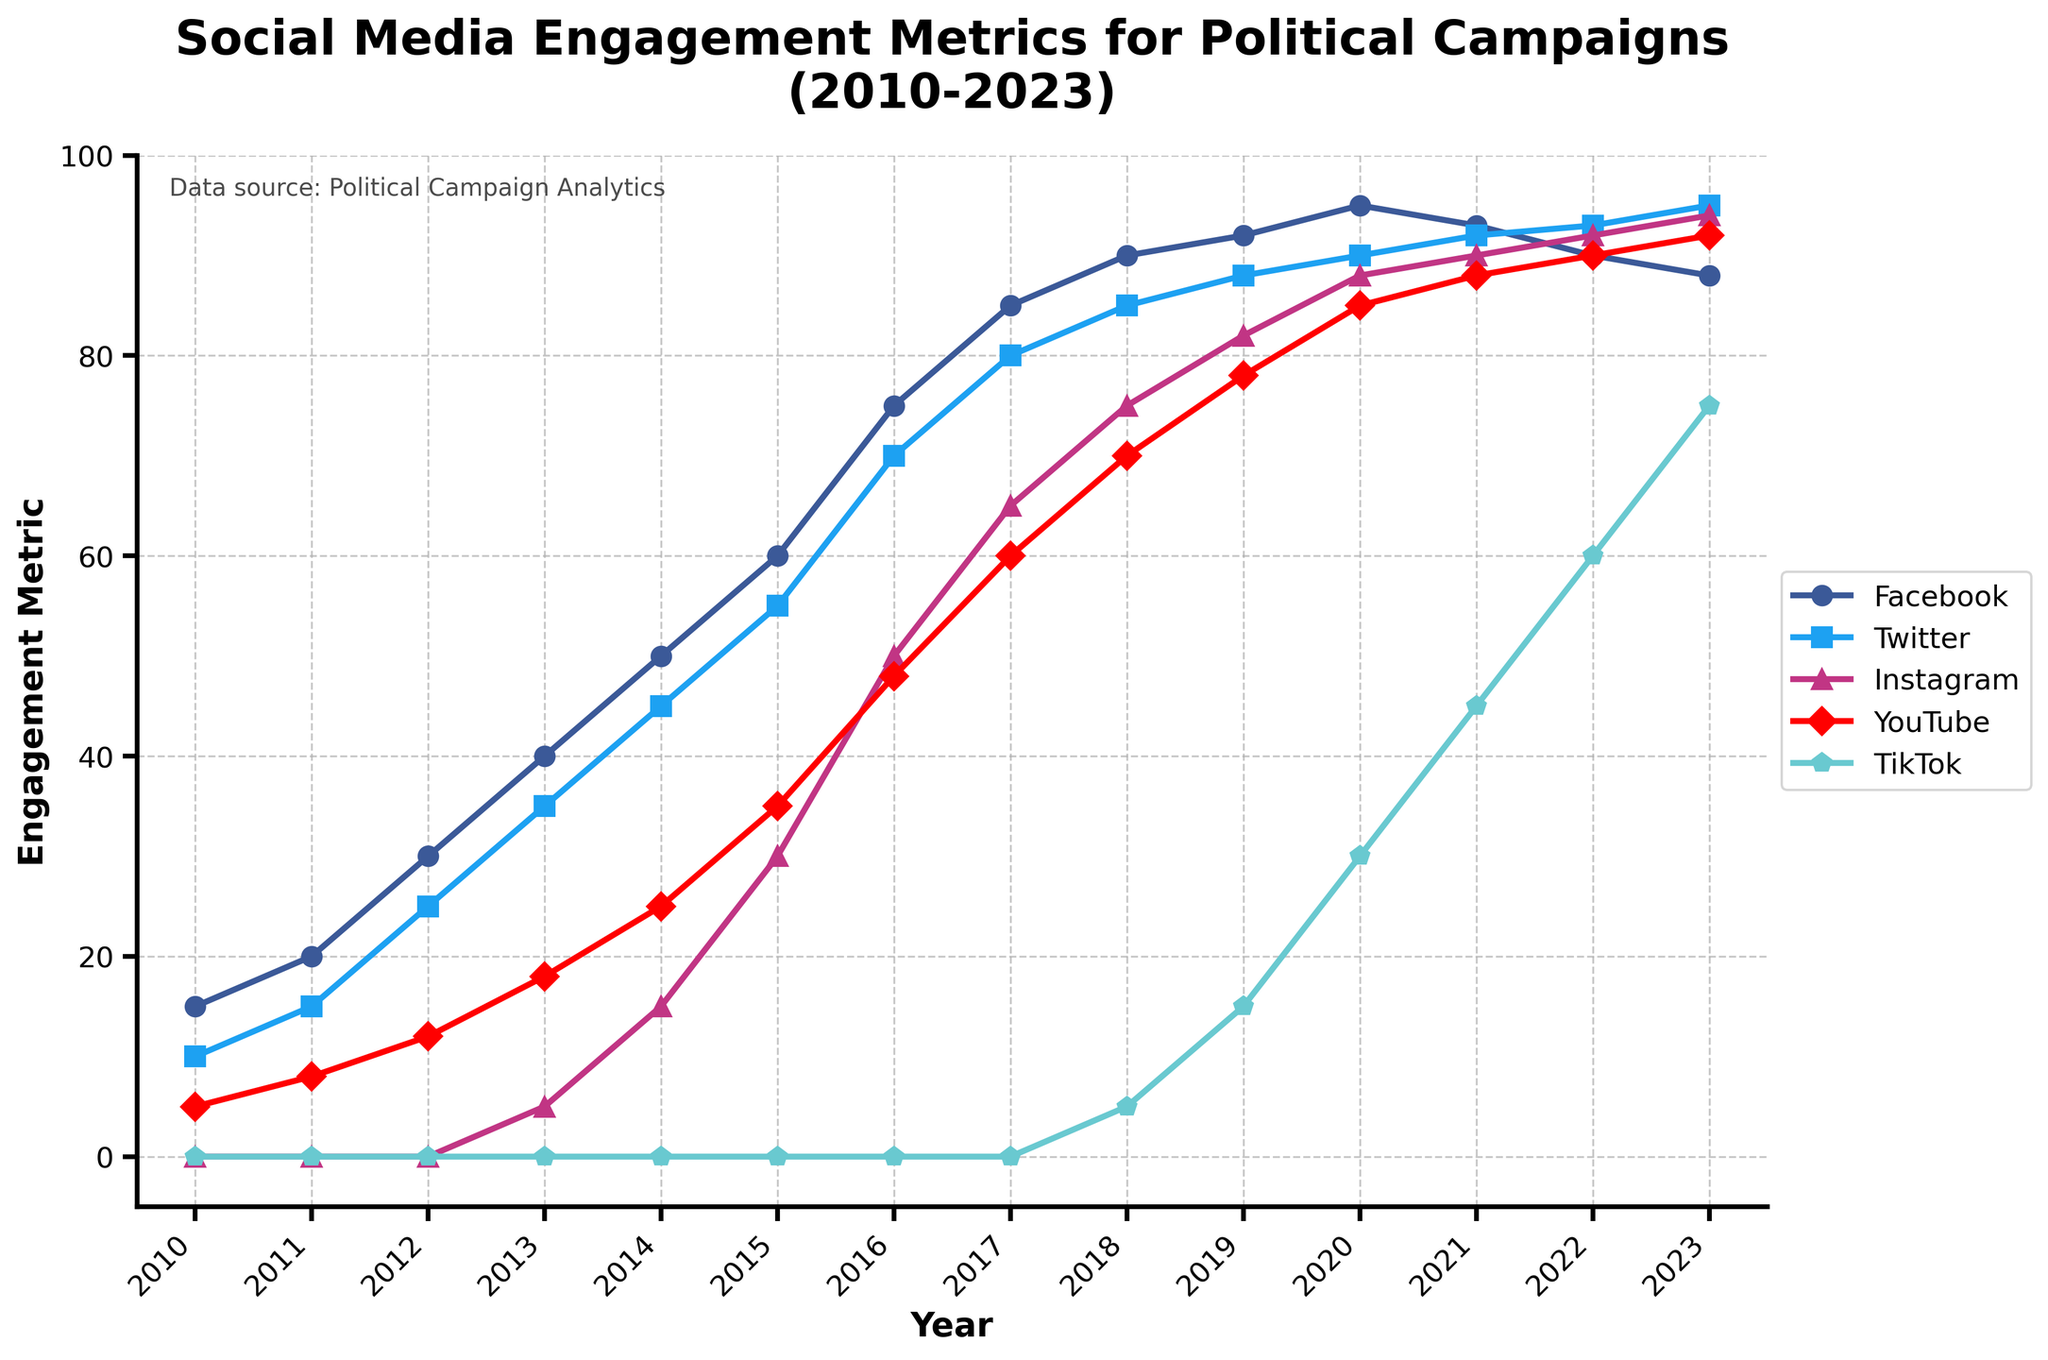How has TikTok's engagement changed from its first appearance in 2018 to 2023? TikTok showed zero engagement from 2010 to 2017. Starting in 2018, its engagement metrics are 5, 15, 30, 45, 60, and 75 in consecutive years up to 2023. This shows steady growth each year.
Answer: Increased from 5 to 75 Which platform had the highest engagement metric in 2023? By examining the endpoints of all lines in 2023, Facebook ends at 88, Twitter at 95, Instagram at 94, YouTube at 92, and TikTok at 75. Twitter has the highest engagement.
Answer: Twitter What year did Instagram start showing engagement metrics and what was the value? By looking at the lines, Instagram starts at the value of 0 up to 2012. From 2013, the line starts at 5.
Answer: 2013 and 5 In which year did YouTube surpass Facebook in engagement metrics? Examining both lines visually, YouTube overtakes Facebook in 2023 when Facebook has 88 and YouTube has 92.
Answer: 2023 From 2010 to 2023, which platform had the most consistent annual growth? TikTok shows the steadiest and most consistent growth pattern, increasing each year by almost the same amount since its introduction in 2018.
Answer: TikTok Between 2012 and 2016, which platform had the largest relative increase in engagement metrics? Facebook: 15 to 75 (60), Twitter: 25 to 70 (45), Instagram: 0 to 50 (50), YouTube: 12 to 48 (36). Instagram had the largest increase.
Answer: Instagram What's the difference in engagement metrics between Twitter and Instagram in 2020? Twitter's value in 2020 is 90 and Instagram's is 88. The difference is 90 - 88.
Answer: 2 Over the years 2011 to 2015, which platform showed a higher total engagement: Facebook or YouTube? Summing the values from 2011 to 2015 for Facebook (20+30+40+50+60 = 200) and for YouTube (8+12+18+25+35 = 98), Facebook showed higher engagement.
Answer: Facebook How did YouTube's engagement change from 2010 to 2013, and what could this imply? YouTube's engagement rose from 5 to 18 from 2010 to 2013, indicating a growing user base and possibly more content integration with political campaigns.
Answer: Increased by 13 In which decade did Facebook achieve its highest annual growth in engagement metrics? To find the highest annual growth, calculate the difference year by year: 2010-11 (5), 2011-12 (10), 2012-13 (10), 2013-14 (10), 2014-15 (10), 2015-16 (15), 2016-17 (10), 2017-18 (5), 2018-19 (2), 2019-20 (3). The year 2015-16 had the highest growth (15).
Answer: 2015-16 